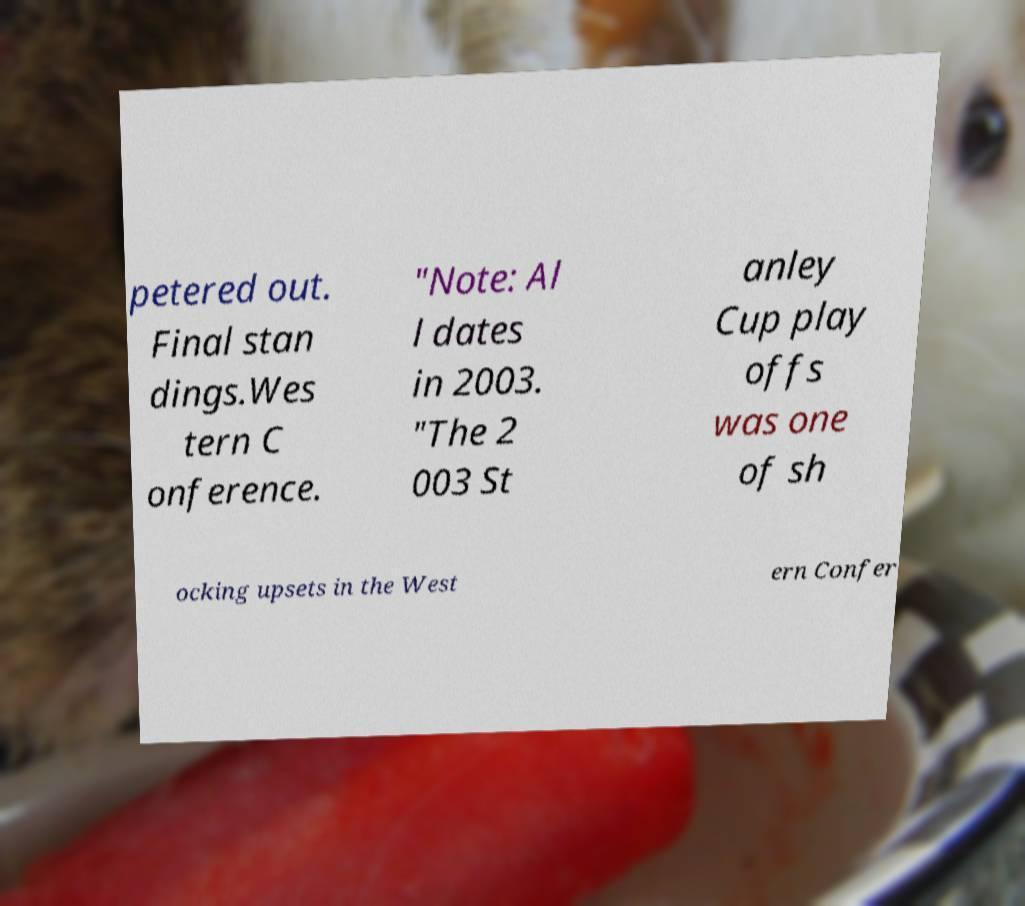Please identify and transcribe the text found in this image. petered out. Final stan dings.Wes tern C onference. "Note: Al l dates in 2003. "The 2 003 St anley Cup play offs was one of sh ocking upsets in the West ern Confer 